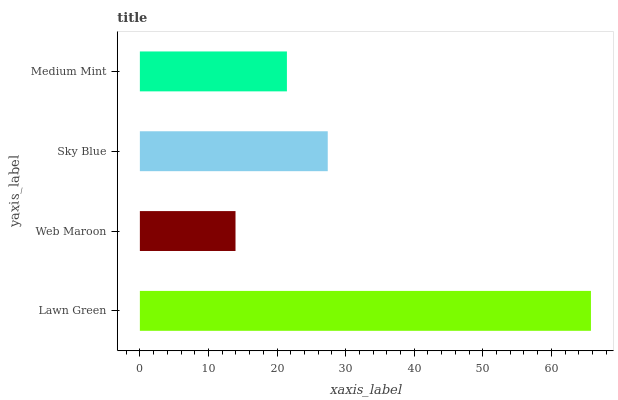Is Web Maroon the minimum?
Answer yes or no. Yes. Is Lawn Green the maximum?
Answer yes or no. Yes. Is Sky Blue the minimum?
Answer yes or no. No. Is Sky Blue the maximum?
Answer yes or no. No. Is Sky Blue greater than Web Maroon?
Answer yes or no. Yes. Is Web Maroon less than Sky Blue?
Answer yes or no. Yes. Is Web Maroon greater than Sky Blue?
Answer yes or no. No. Is Sky Blue less than Web Maroon?
Answer yes or no. No. Is Sky Blue the high median?
Answer yes or no. Yes. Is Medium Mint the low median?
Answer yes or no. Yes. Is Lawn Green the high median?
Answer yes or no. No. Is Sky Blue the low median?
Answer yes or no. No. 